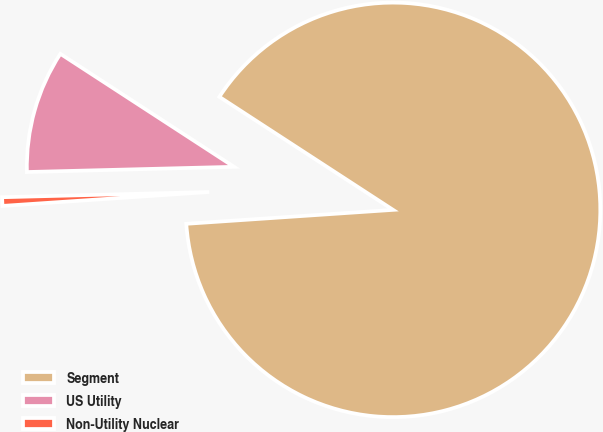Convert chart to OTSL. <chart><loc_0><loc_0><loc_500><loc_500><pie_chart><fcel>Segment<fcel>US Utility<fcel>Non-Utility Nuclear<nl><fcel>89.75%<fcel>9.58%<fcel>0.67%<nl></chart> 